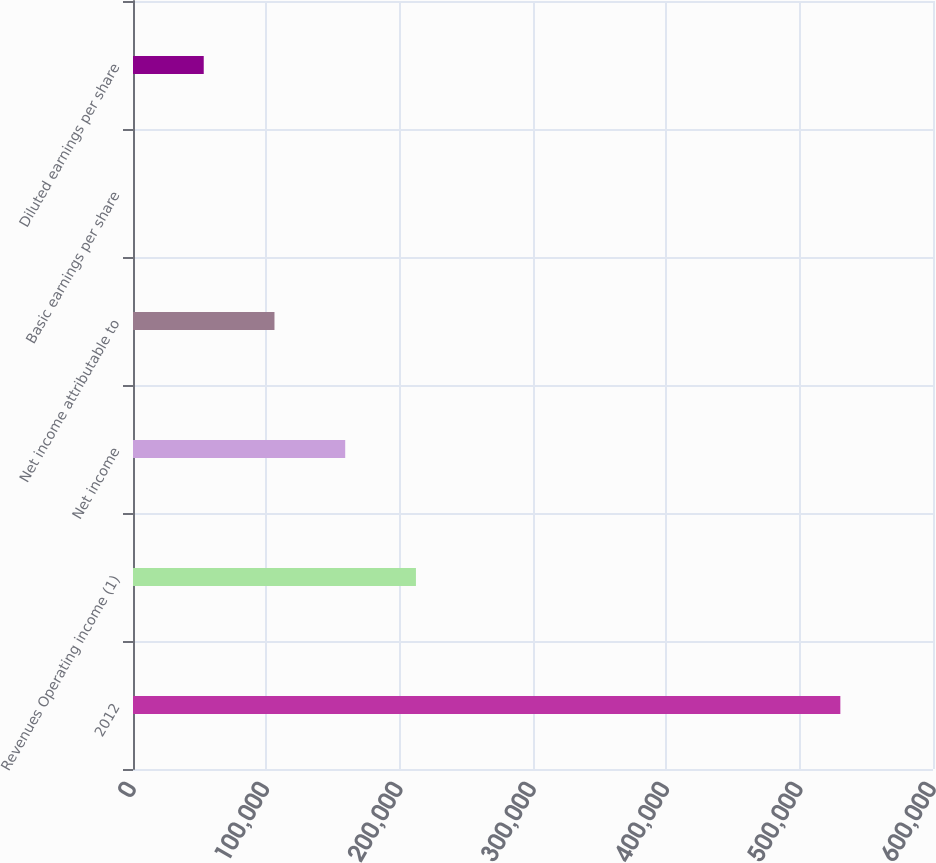Convert chart. <chart><loc_0><loc_0><loc_500><loc_500><bar_chart><fcel>2012<fcel>Revenues Operating income (1)<fcel>Net income<fcel>Net income attributable to<fcel>Basic earnings per share<fcel>Diluted earnings per share<nl><fcel>530505<fcel>212202<fcel>159152<fcel>106102<fcel>0.78<fcel>53051.2<nl></chart> 